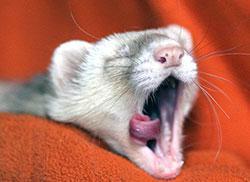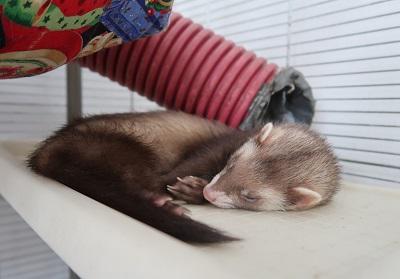The first image is the image on the left, the second image is the image on the right. Analyze the images presented: Is the assertion "Not even one of the animals appears to be awake and alert; they all seem tired, or are sleeping." valid? Answer yes or no. Yes. The first image is the image on the left, the second image is the image on the right. Given the left and right images, does the statement "One ferret has its tongue sticking out." hold true? Answer yes or no. Yes. 